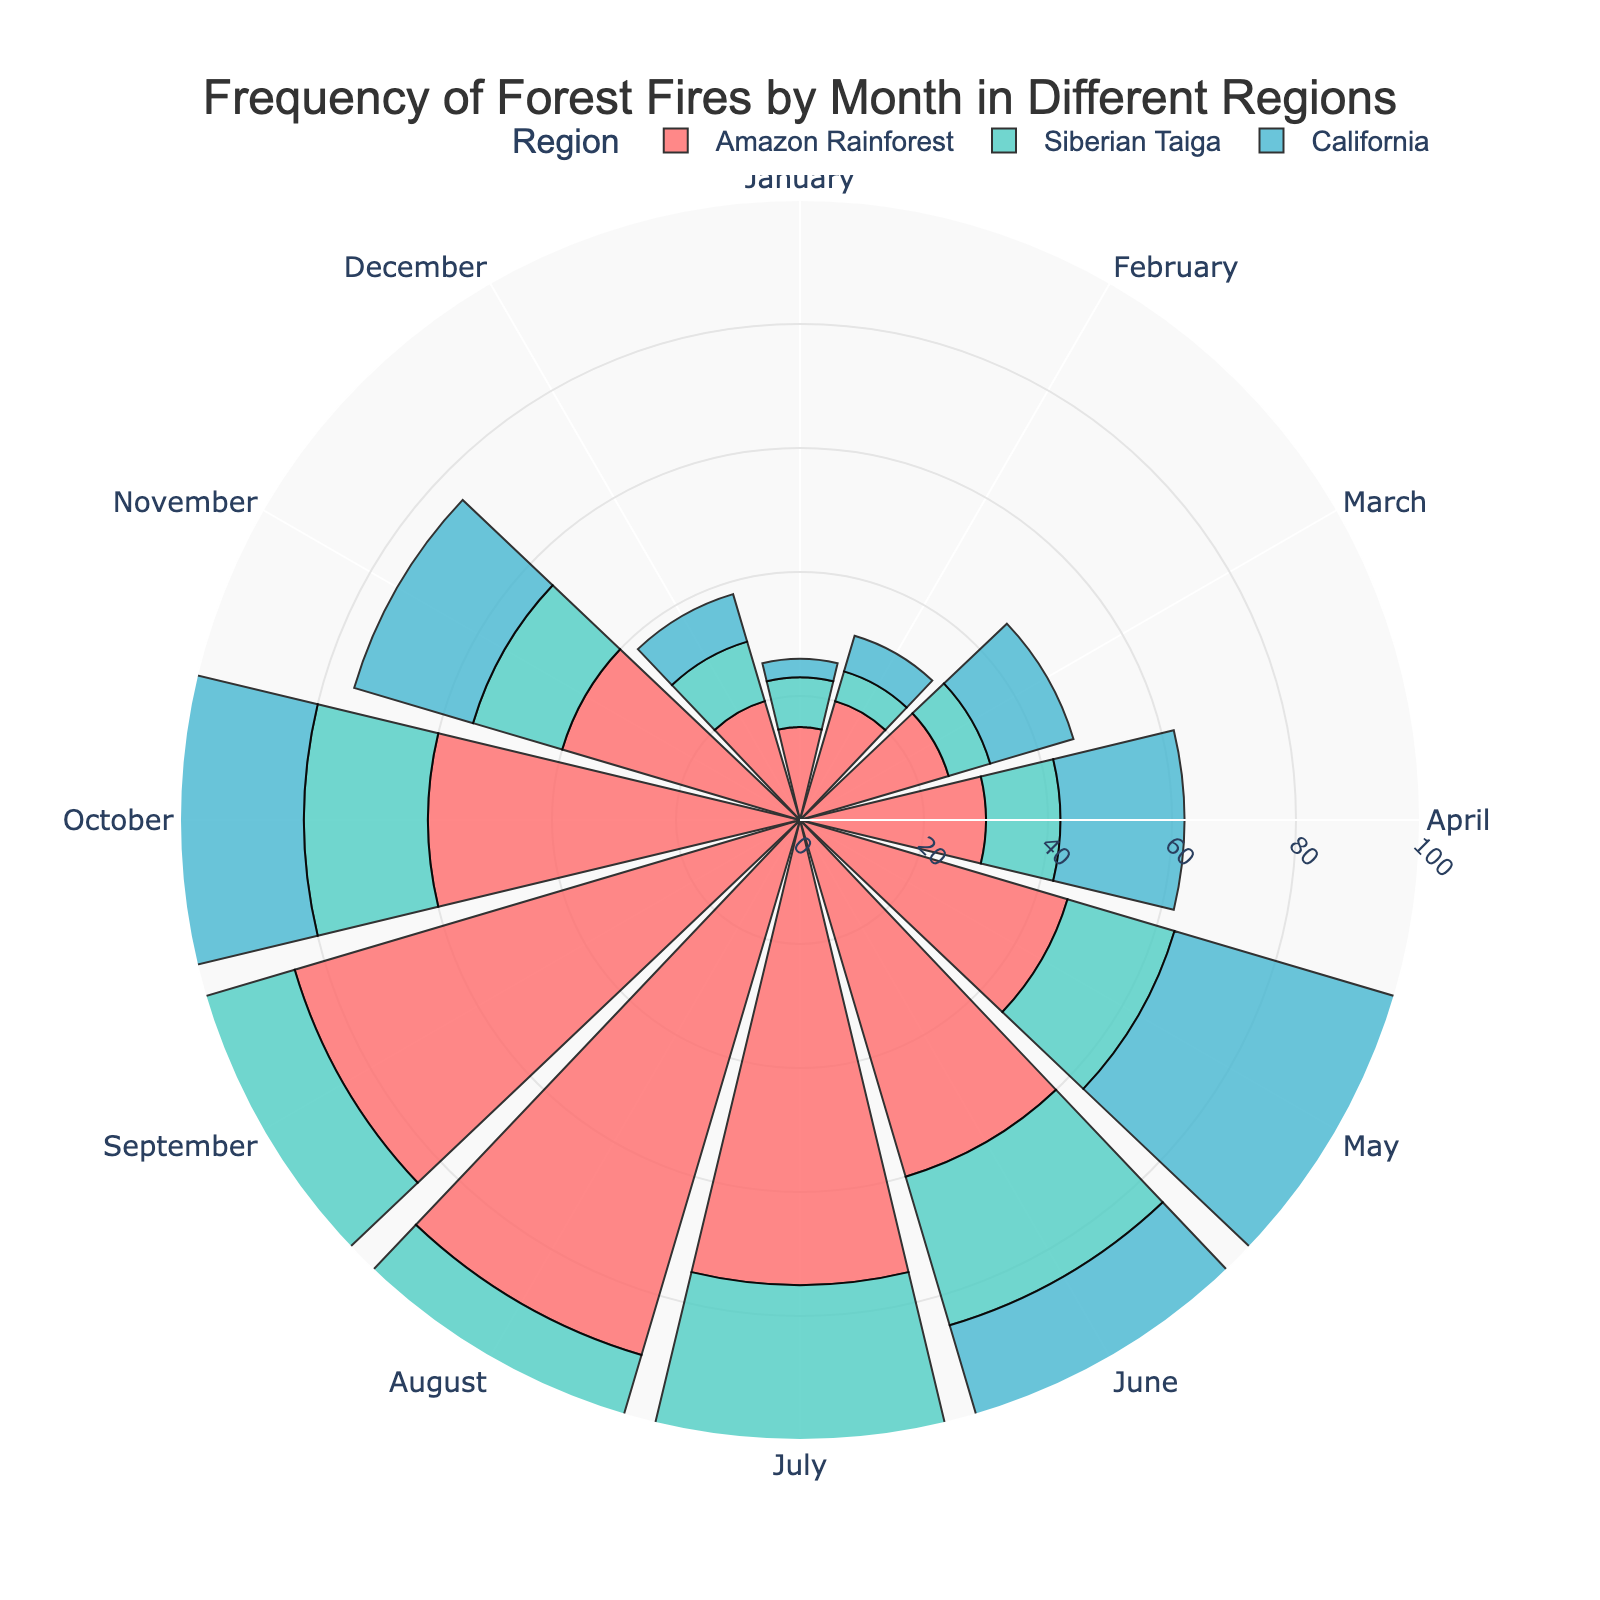What is the title of the rose chart? The title of the rose chart is typically displayed prominently at the top of the chart, written in a larger font size for visibility. It says "Frequency of Forest Fires by Month in Different Regions".
Answer: Frequency of Forest Fires by Month in Different Regions Which region has the highest number of forest fires in August? By observing the lengths of the bars for the month of August on the rose chart, we can see which region has the longest bar. California has the highest number as it reaches up to 100.
Answer: California In which months does the Amazon Rainforest have more than 80 forest fires? Look at the bars corresponding to the Amazon Rainforest and identify those which exceed the 80 mark. The Amazon Rainforest has more than 80 forest fires in July, August, and September.
Answer: July, August, September How many forest fires were there in the Siberian Taiga in the first quarter of the year? Add up the number of forest fires in January, February, and March for the Siberian Taiga. 8 (January) + 5 (February) + 7 (March) = 20 forest fires.
Answer: 20 Which month has the lowest frequency of forest fires in California? Identify the bar with the lowest value for California. January has the lowest frequency with only 3 fires.
Answer: January How does the frequency of forest fires in June compare between the Amazon Rainforest and California? By comparing the bars for June in the Amazon Rainforest and California, we see that California has more forest fires (70) compared to the Amazon Rainforest (60).
Answer: California has more fires in June During which months do all regions show an increasing trend in forest fire frequency? Check the bars sequentially for each region to see where they all increase compared to the previous month. All regions show an increasing trend in May, June, and July.
Answer: May, June, July What is the average frequency of forest fires in the Amazon Rainforest over the year? Add up the frequency for each month and then divide by 12 (number of months): (15+20+25+30+45+60+75+90+85+60+40+20)/12 = 46.25.
Answer: 46.25 Compare the frequency of forest fires in the Siberian Taiga in April and October. What is the difference? Subtract the frequency in October from that in April for the Siberian Taiga. 12 (April) - 20 (October) = -8.
Answer: -8 Which region showed the most significant increase in forest fires from January to July? Calculate the increase for each region from January to July and compare: Amazon Rainforest (75-15=60), Siberian Taiga (30-8=22), California (90-3=87). California shows the most significant increase.
Answer: California 